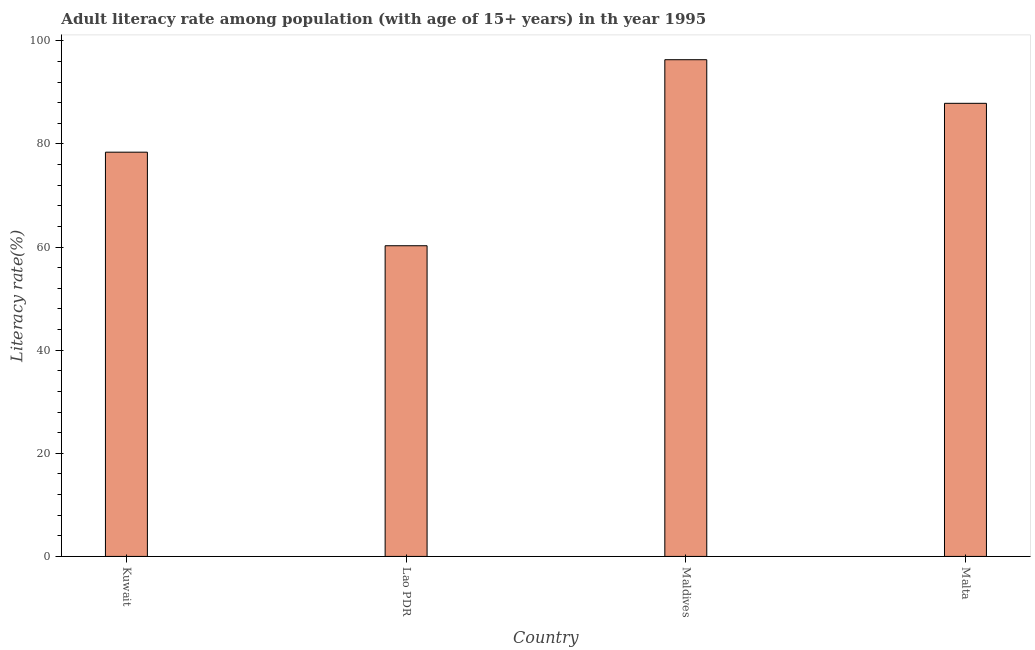Does the graph contain grids?
Ensure brevity in your answer.  No. What is the title of the graph?
Provide a short and direct response. Adult literacy rate among population (with age of 15+ years) in th year 1995. What is the label or title of the X-axis?
Your answer should be very brief. Country. What is the label or title of the Y-axis?
Keep it short and to the point. Literacy rate(%). What is the adult literacy rate in Lao PDR?
Give a very brief answer. 60.25. Across all countries, what is the maximum adult literacy rate?
Give a very brief answer. 96.33. Across all countries, what is the minimum adult literacy rate?
Ensure brevity in your answer.  60.25. In which country was the adult literacy rate maximum?
Ensure brevity in your answer.  Maldives. In which country was the adult literacy rate minimum?
Keep it short and to the point. Lao PDR. What is the sum of the adult literacy rate?
Give a very brief answer. 322.84. What is the difference between the adult literacy rate in Kuwait and Malta?
Offer a terse response. -9.47. What is the average adult literacy rate per country?
Make the answer very short. 80.71. What is the median adult literacy rate?
Give a very brief answer. 83.13. What is the ratio of the adult literacy rate in Kuwait to that in Lao PDR?
Provide a short and direct response. 1.3. Is the adult literacy rate in Kuwait less than that in Malta?
Ensure brevity in your answer.  Yes. What is the difference between the highest and the second highest adult literacy rate?
Offer a very short reply. 8.46. What is the difference between the highest and the lowest adult literacy rate?
Offer a very short reply. 36.08. How many countries are there in the graph?
Your response must be concise. 4. What is the Literacy rate(%) of Kuwait?
Give a very brief answer. 78.4. What is the Literacy rate(%) in Lao PDR?
Offer a very short reply. 60.25. What is the Literacy rate(%) of Maldives?
Keep it short and to the point. 96.33. What is the Literacy rate(%) in Malta?
Provide a succinct answer. 87.87. What is the difference between the Literacy rate(%) in Kuwait and Lao PDR?
Keep it short and to the point. 18.14. What is the difference between the Literacy rate(%) in Kuwait and Maldives?
Ensure brevity in your answer.  -17.93. What is the difference between the Literacy rate(%) in Kuwait and Malta?
Make the answer very short. -9.47. What is the difference between the Literacy rate(%) in Lao PDR and Maldives?
Your answer should be compact. -36.08. What is the difference between the Literacy rate(%) in Lao PDR and Malta?
Your response must be concise. -27.62. What is the difference between the Literacy rate(%) in Maldives and Malta?
Make the answer very short. 8.46. What is the ratio of the Literacy rate(%) in Kuwait to that in Lao PDR?
Provide a succinct answer. 1.3. What is the ratio of the Literacy rate(%) in Kuwait to that in Maldives?
Provide a short and direct response. 0.81. What is the ratio of the Literacy rate(%) in Kuwait to that in Malta?
Give a very brief answer. 0.89. What is the ratio of the Literacy rate(%) in Lao PDR to that in Maldives?
Give a very brief answer. 0.62. What is the ratio of the Literacy rate(%) in Lao PDR to that in Malta?
Ensure brevity in your answer.  0.69. What is the ratio of the Literacy rate(%) in Maldives to that in Malta?
Your answer should be compact. 1.1. 